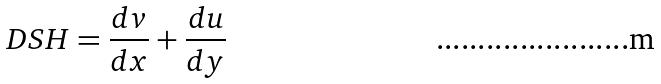<formula> <loc_0><loc_0><loc_500><loc_500>D S H = \frac { d v } { d x } + \frac { d u } { d y }</formula> 